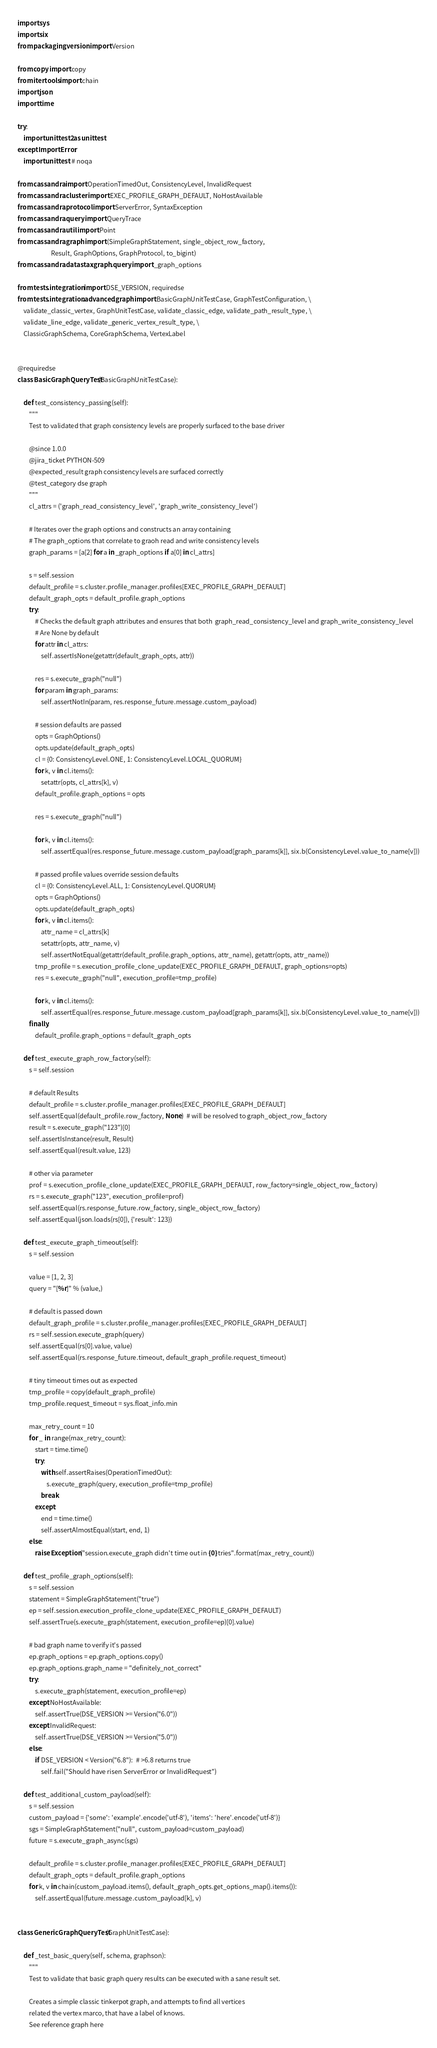<code> <loc_0><loc_0><loc_500><loc_500><_Python_>import sys
import six
from packaging.version import Version

from copy import copy
from itertools import chain
import json
import time

try:
    import unittest2 as unittest
except ImportError:
    import unittest  # noqa

from cassandra import OperationTimedOut, ConsistencyLevel, InvalidRequest
from cassandra.cluster import EXEC_PROFILE_GRAPH_DEFAULT, NoHostAvailable
from cassandra.protocol import ServerError, SyntaxException
from cassandra.query import QueryTrace
from cassandra.util import Point
from cassandra.graph import (SimpleGraphStatement, single_object_row_factory,
                       Result, GraphOptions, GraphProtocol, to_bigint)
from cassandra.datastax.graph.query import _graph_options

from tests.integration import DSE_VERSION, requiredse
from tests.integration.advanced.graph import BasicGraphUnitTestCase, GraphTestConfiguration, \
    validate_classic_vertex, GraphUnitTestCase, validate_classic_edge, validate_path_result_type, \
    validate_line_edge, validate_generic_vertex_result_type, \
    ClassicGraphSchema, CoreGraphSchema, VertexLabel


@requiredse
class BasicGraphQueryTest(BasicGraphUnitTestCase):

    def test_consistency_passing(self):
        """
        Test to validated that graph consistency levels are properly surfaced to the base driver

        @since 1.0.0
        @jira_ticket PYTHON-509
        @expected_result graph consistency levels are surfaced correctly
        @test_category dse graph
        """
        cl_attrs = ('graph_read_consistency_level', 'graph_write_consistency_level')

        # Iterates over the graph options and constructs an array containing
        # The graph_options that correlate to graoh read and write consistency levels
        graph_params = [a[2] for a in _graph_options if a[0] in cl_attrs]

        s = self.session
        default_profile = s.cluster.profile_manager.profiles[EXEC_PROFILE_GRAPH_DEFAULT]
        default_graph_opts = default_profile.graph_options
        try:
            # Checks the default graph attributes and ensures that both  graph_read_consistency_level and graph_write_consistency_level
            # Are None by default
            for attr in cl_attrs:
                self.assertIsNone(getattr(default_graph_opts, attr))

            res = s.execute_graph("null")
            for param in graph_params:
                self.assertNotIn(param, res.response_future.message.custom_payload)

            # session defaults are passed
            opts = GraphOptions()
            opts.update(default_graph_opts)
            cl = {0: ConsistencyLevel.ONE, 1: ConsistencyLevel.LOCAL_QUORUM}
            for k, v in cl.items():
                setattr(opts, cl_attrs[k], v)
            default_profile.graph_options = opts

            res = s.execute_graph("null")

            for k, v in cl.items():
                self.assertEqual(res.response_future.message.custom_payload[graph_params[k]], six.b(ConsistencyLevel.value_to_name[v]))

            # passed profile values override session defaults
            cl = {0: ConsistencyLevel.ALL, 1: ConsistencyLevel.QUORUM}
            opts = GraphOptions()
            opts.update(default_graph_opts)
            for k, v in cl.items():
                attr_name = cl_attrs[k]
                setattr(opts, attr_name, v)
                self.assertNotEqual(getattr(default_profile.graph_options, attr_name), getattr(opts, attr_name))
            tmp_profile = s.execution_profile_clone_update(EXEC_PROFILE_GRAPH_DEFAULT, graph_options=opts)
            res = s.execute_graph("null", execution_profile=tmp_profile)

            for k, v in cl.items():
                self.assertEqual(res.response_future.message.custom_payload[graph_params[k]], six.b(ConsistencyLevel.value_to_name[v]))
        finally:
            default_profile.graph_options = default_graph_opts

    def test_execute_graph_row_factory(self):
        s = self.session

        # default Results
        default_profile = s.cluster.profile_manager.profiles[EXEC_PROFILE_GRAPH_DEFAULT]
        self.assertEqual(default_profile.row_factory, None)  # will be resolved to graph_object_row_factory
        result = s.execute_graph("123")[0]
        self.assertIsInstance(result, Result)
        self.assertEqual(result.value, 123)

        # other via parameter
        prof = s.execution_profile_clone_update(EXEC_PROFILE_GRAPH_DEFAULT, row_factory=single_object_row_factory)
        rs = s.execute_graph("123", execution_profile=prof)
        self.assertEqual(rs.response_future.row_factory, single_object_row_factory)
        self.assertEqual(json.loads(rs[0]), {'result': 123})

    def test_execute_graph_timeout(self):
        s = self.session

        value = [1, 2, 3]
        query = "[%r]" % (value,)

        # default is passed down
        default_graph_profile = s.cluster.profile_manager.profiles[EXEC_PROFILE_GRAPH_DEFAULT]
        rs = self.session.execute_graph(query)
        self.assertEqual(rs[0].value, value)
        self.assertEqual(rs.response_future.timeout, default_graph_profile.request_timeout)

        # tiny timeout times out as expected
        tmp_profile = copy(default_graph_profile)
        tmp_profile.request_timeout = sys.float_info.min

        max_retry_count = 10
        for _ in range(max_retry_count):
            start = time.time()
            try:
                with self.assertRaises(OperationTimedOut):
                    s.execute_graph(query, execution_profile=tmp_profile)
                break
            except:
                end = time.time()
                self.assertAlmostEqual(start, end, 1)
        else:
            raise Exception("session.execute_graph didn't time out in {0} tries".format(max_retry_count))

    def test_profile_graph_options(self):
        s = self.session
        statement = SimpleGraphStatement("true")
        ep = self.session.execution_profile_clone_update(EXEC_PROFILE_GRAPH_DEFAULT)
        self.assertTrue(s.execute_graph(statement, execution_profile=ep)[0].value)

        # bad graph name to verify it's passed
        ep.graph_options = ep.graph_options.copy()
        ep.graph_options.graph_name = "definitely_not_correct"
        try:
            s.execute_graph(statement, execution_profile=ep)
        except NoHostAvailable:
            self.assertTrue(DSE_VERSION >= Version("6.0"))
        except InvalidRequest:
            self.assertTrue(DSE_VERSION >= Version("5.0"))
        else:
            if DSE_VERSION < Version("6.8"):  # >6.8 returns true
                self.fail("Should have risen ServerError or InvalidRequest")

    def test_additional_custom_payload(self):
        s = self.session
        custom_payload = {'some': 'example'.encode('utf-8'), 'items': 'here'.encode('utf-8')}
        sgs = SimpleGraphStatement("null", custom_payload=custom_payload)
        future = s.execute_graph_async(sgs)

        default_profile = s.cluster.profile_manager.profiles[EXEC_PROFILE_GRAPH_DEFAULT]
        default_graph_opts = default_profile.graph_options
        for k, v in chain(custom_payload.items(), default_graph_opts.get_options_map().items()):
            self.assertEqual(future.message.custom_payload[k], v)


class GenericGraphQueryTest(GraphUnitTestCase):

    def _test_basic_query(self, schema, graphson):
        """
        Test to validate that basic graph query results can be executed with a sane result set.

        Creates a simple classic tinkerpot graph, and attempts to find all vertices
        related the vertex marco, that have a label of knows.
        See reference graph here</code> 